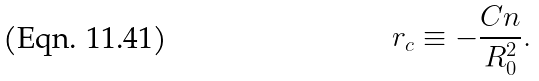Convert formula to latex. <formula><loc_0><loc_0><loc_500><loc_500>r _ { c } \equiv - \frac { C n } { R _ { 0 } ^ { 2 } } .</formula> 